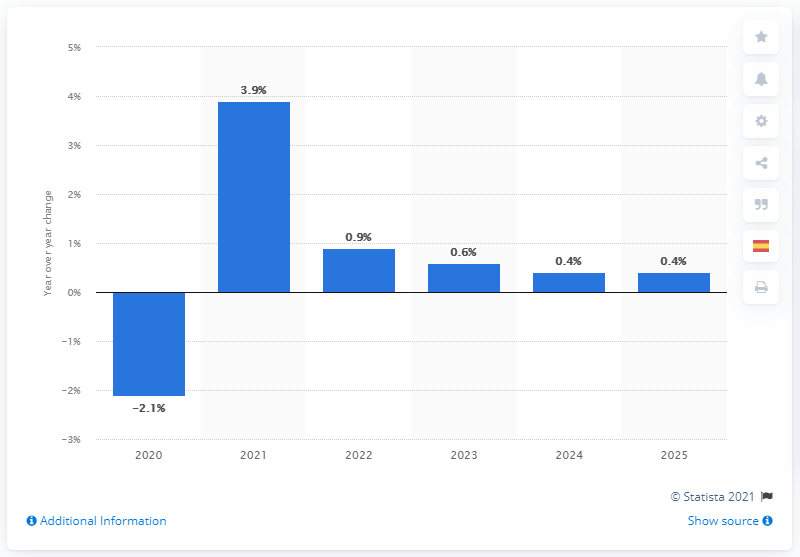Identify some key points in this picture. The output of the paper end-use market is expected to increase by 0.4% by 2025. In the year 2025, the output of the paper end-use market is expected to increase by 0.4 percent. 